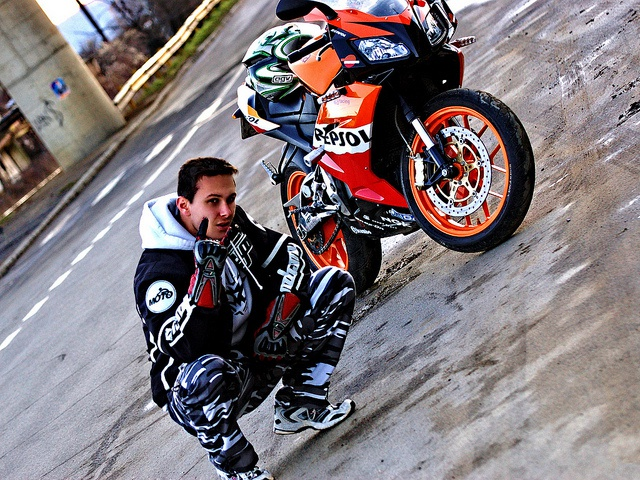Describe the objects in this image and their specific colors. I can see motorcycle in gray, black, white, red, and brown tones and people in gray, black, white, navy, and darkgray tones in this image. 